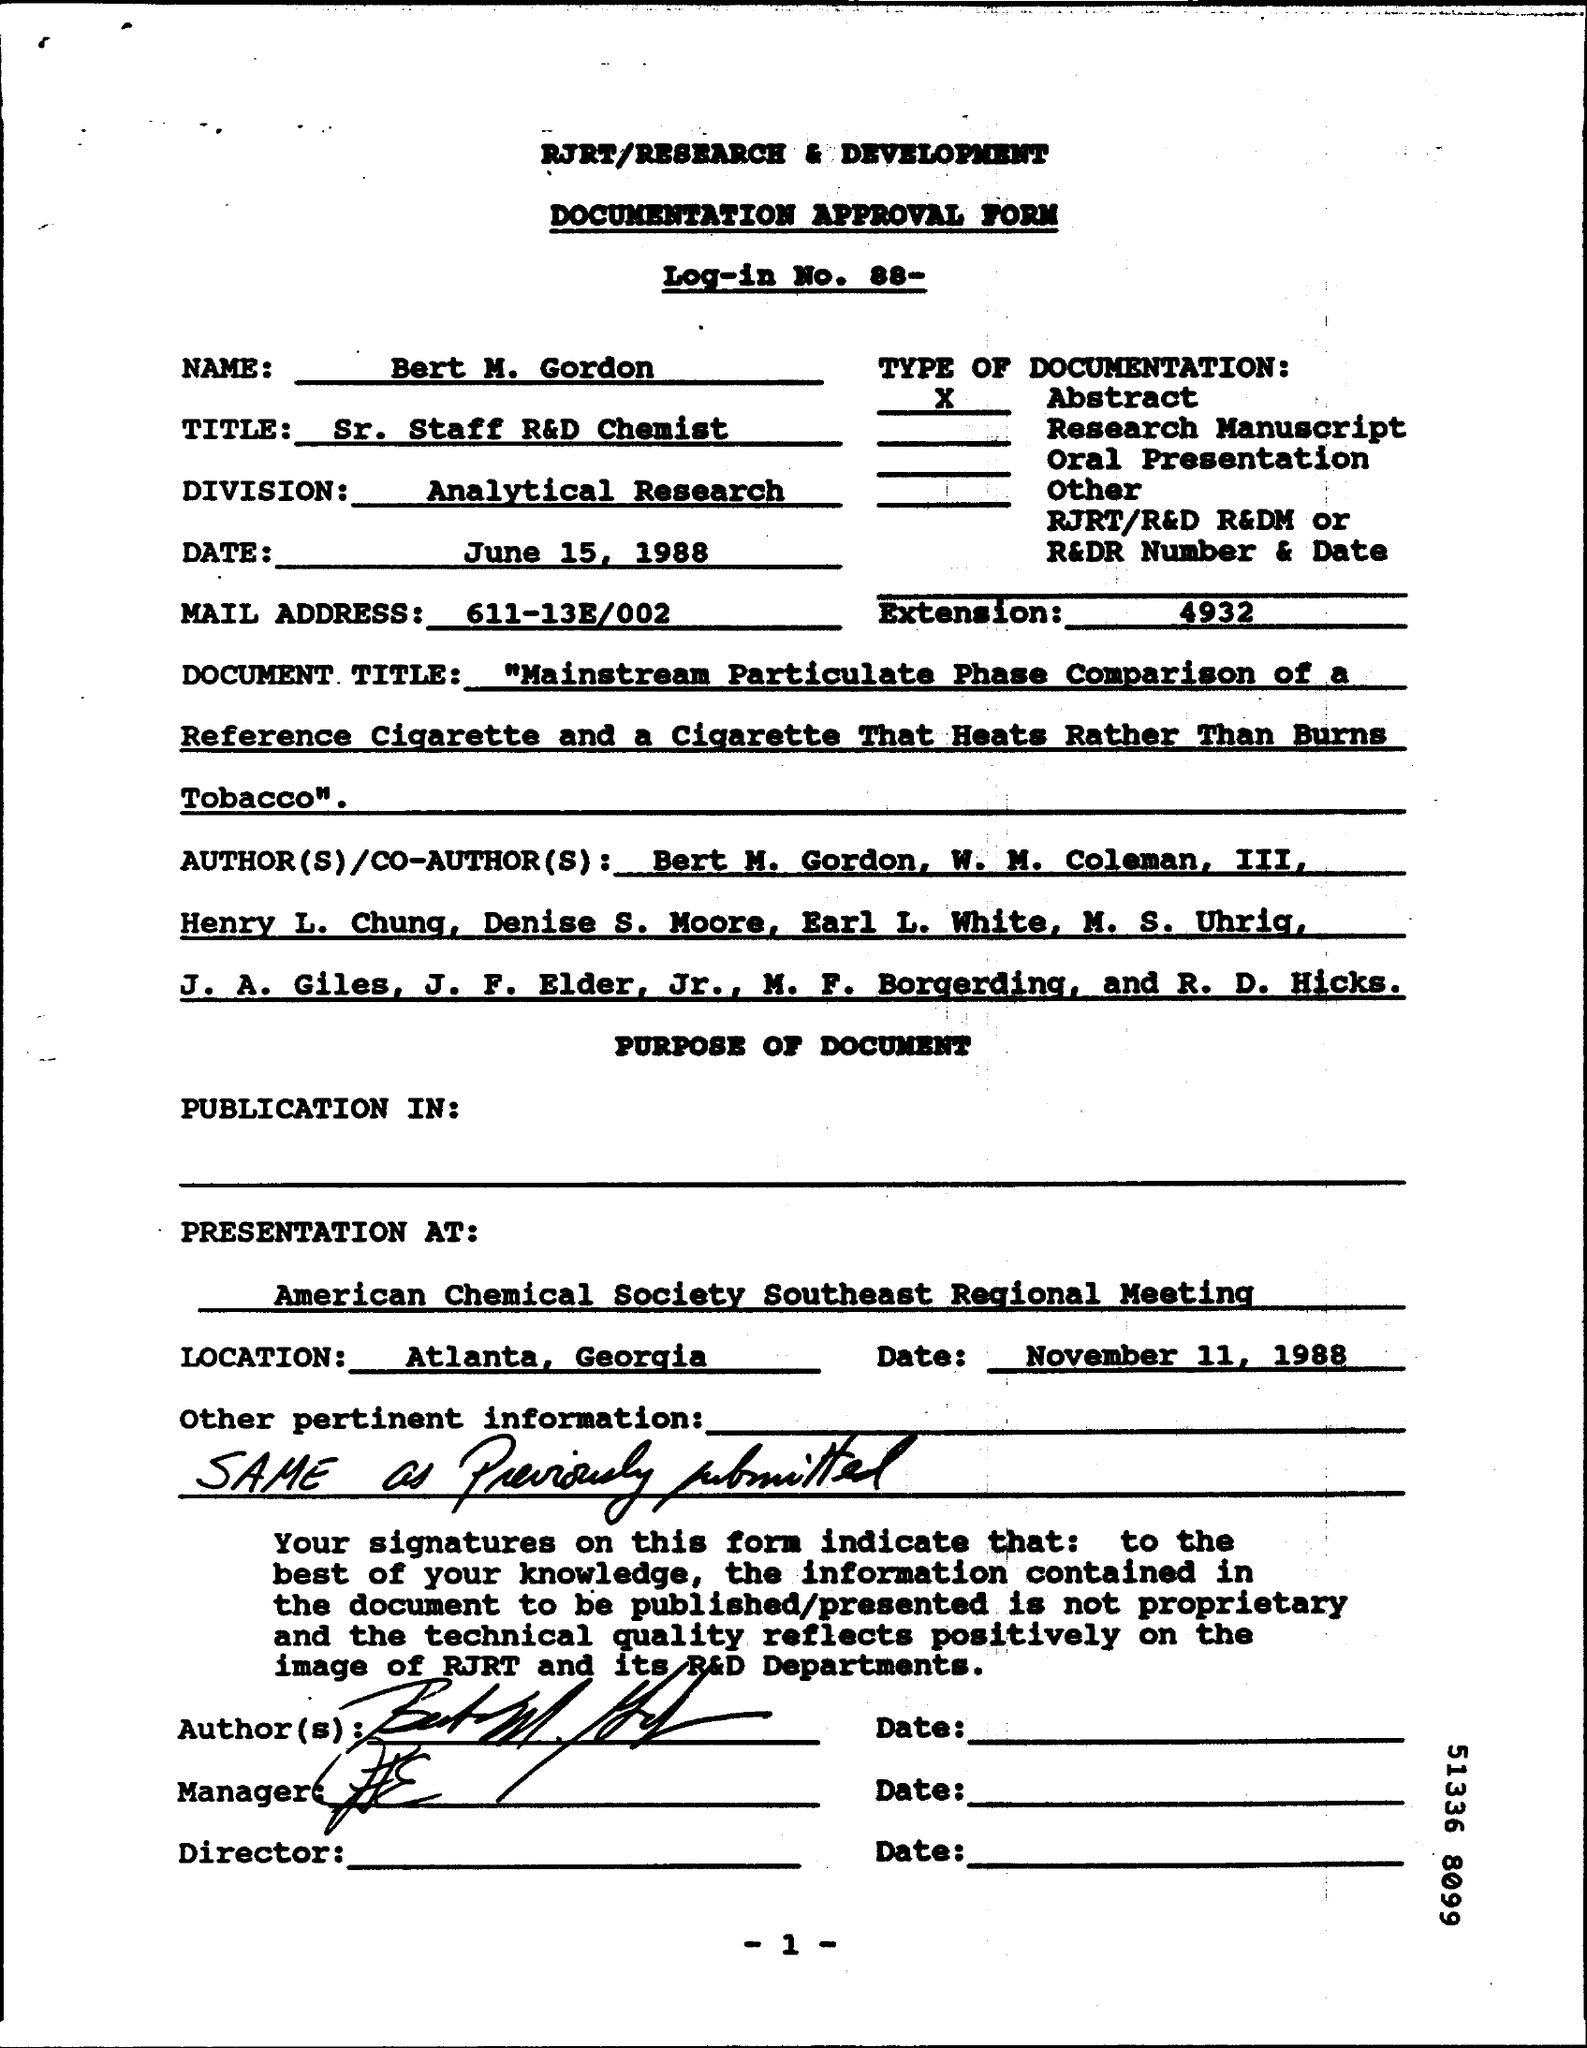What type of form is this?
Your response must be concise. DOCUMENTATION APPROVAL FORM. What is Bert's title?
Provide a short and direct response. Sr. Staff R&D Chemist. What is the type of documentation?
Ensure brevity in your answer.  Abstract. When is the document dated?
Your answer should be very brief. June 15, 1988. Where is the presentation at?
Keep it short and to the point. American Chemical Society Southeast Regional Meeting. When is the presentation?
Provide a succinct answer. November 11, 1988. 